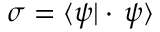<formula> <loc_0><loc_0><loc_500><loc_500>\sigma = \langle \psi | \cdot \, \psi \rangle</formula> 